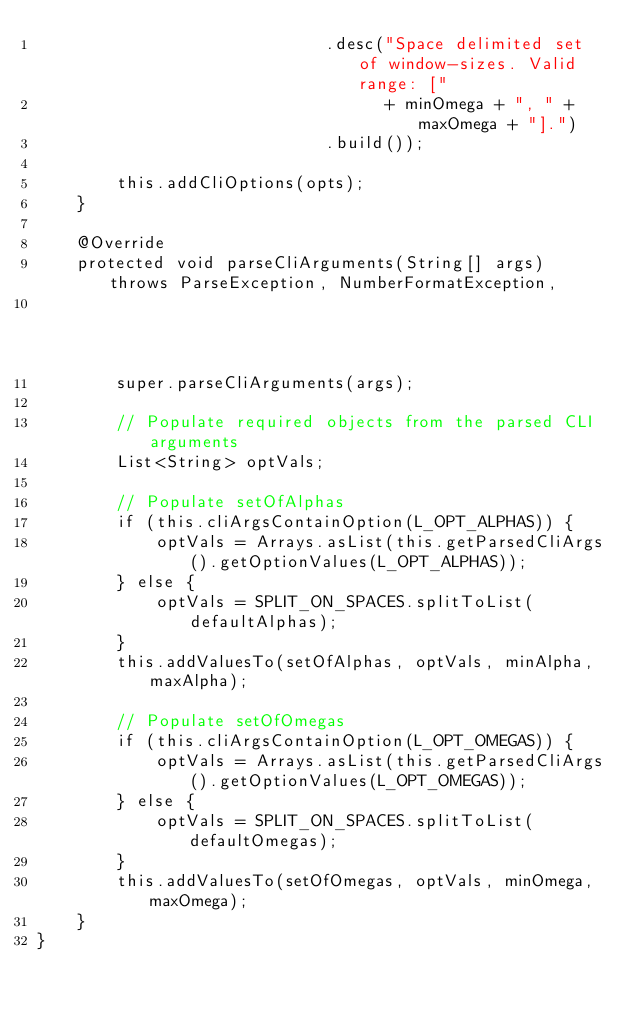Convert code to text. <code><loc_0><loc_0><loc_500><loc_500><_Java_>                             .desc("Space delimited set of window-sizes. Valid range: ["
                                   + minOmega + ", " + maxOmega + "].")
                             .build());

        this.addCliOptions(opts);
    }

    @Override
    protected void parseCliArguments(String[] args) throws ParseException, NumberFormatException,
                                                                           IllegalArgumentException {
        super.parseCliArguments(args);

        // Populate required objects from the parsed CLI arguments
        List<String> optVals;
        
        // Populate setOfAlphas
        if (this.cliArgsContainOption(L_OPT_ALPHAS)) {
            optVals = Arrays.asList(this.getParsedCliArgs().getOptionValues(L_OPT_ALPHAS));
        } else {
            optVals = SPLIT_ON_SPACES.splitToList(defaultAlphas);
        }
        this.addValuesTo(setOfAlphas, optVals, minAlpha, maxAlpha);

        // Populate setOfOmegas
        if (this.cliArgsContainOption(L_OPT_OMEGAS)) {
            optVals = Arrays.asList(this.getParsedCliArgs().getOptionValues(L_OPT_OMEGAS));
        } else {
            optVals = SPLIT_ON_SPACES.splitToList(defaultOmegas);
        }
        this.addValuesTo(setOfOmegas, optVals, minOmega, maxOmega);
    }
}
</code> 